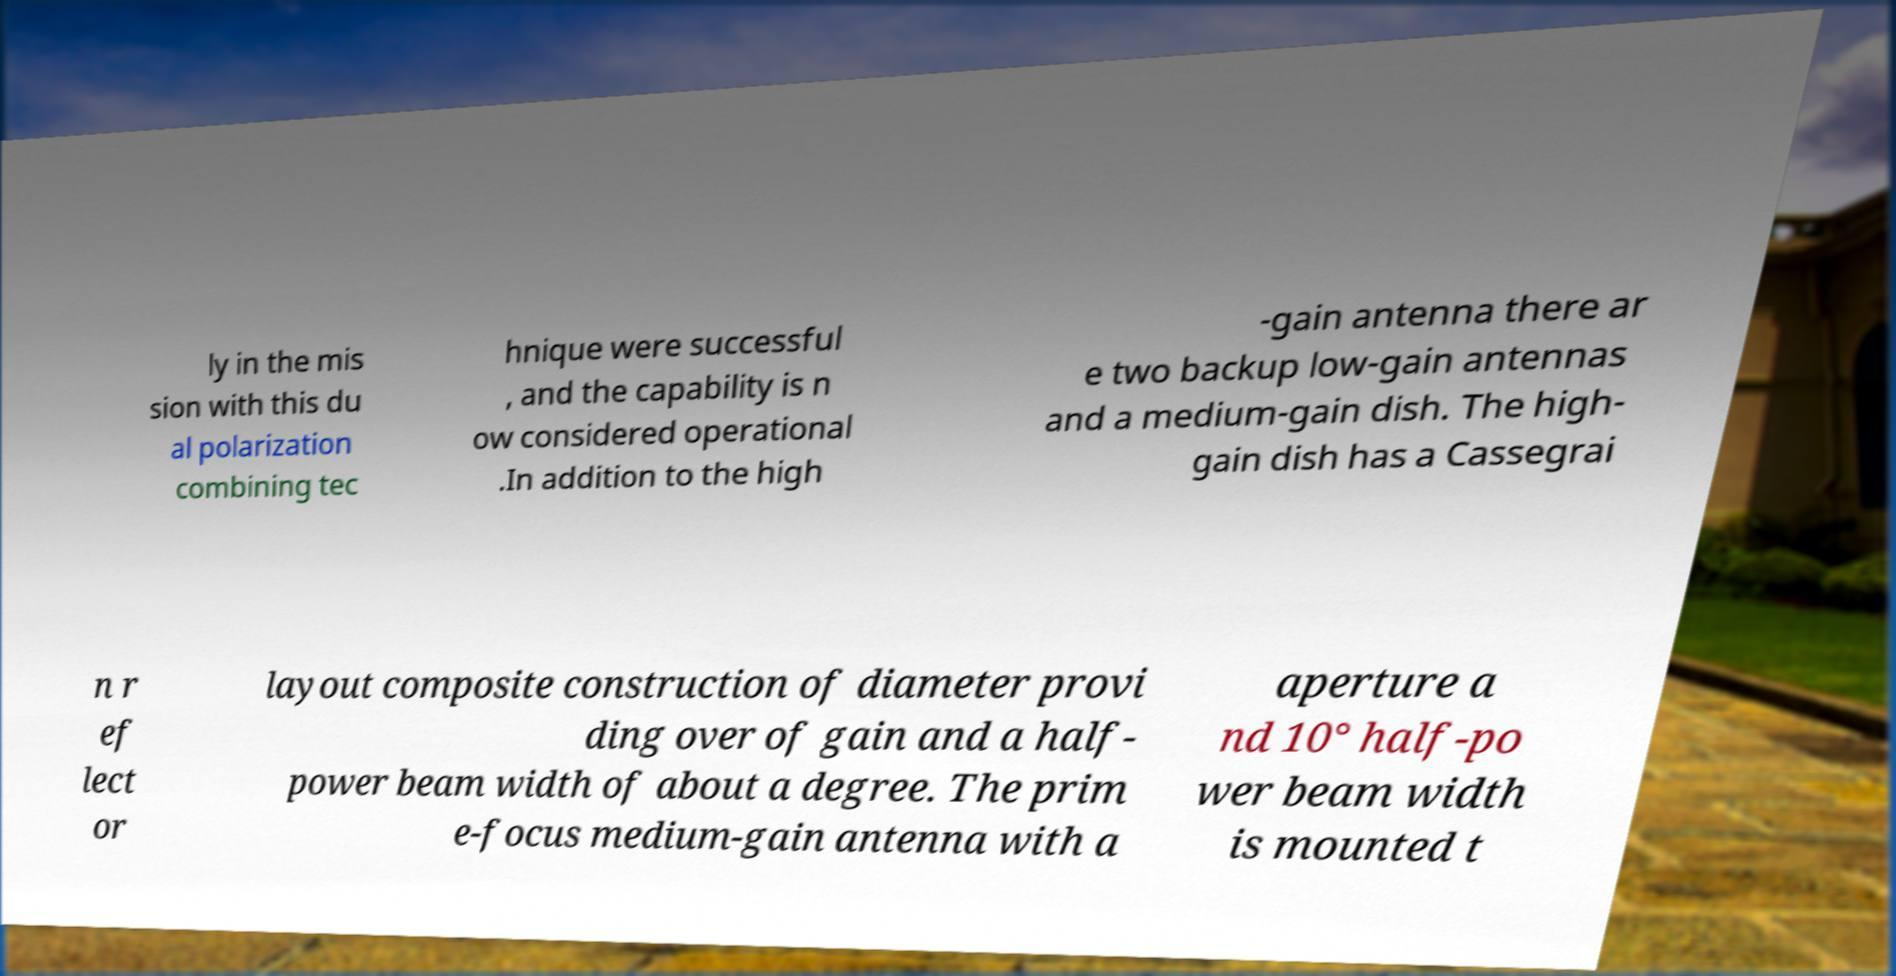Please identify and transcribe the text found in this image. ly in the mis sion with this du al polarization combining tec hnique were successful , and the capability is n ow considered operational .In addition to the high -gain antenna there ar e two backup low-gain antennas and a medium-gain dish. The high- gain dish has a Cassegrai n r ef lect or layout composite construction of diameter provi ding over of gain and a half- power beam width of about a degree. The prim e-focus medium-gain antenna with a aperture a nd 10° half-po wer beam width is mounted t 